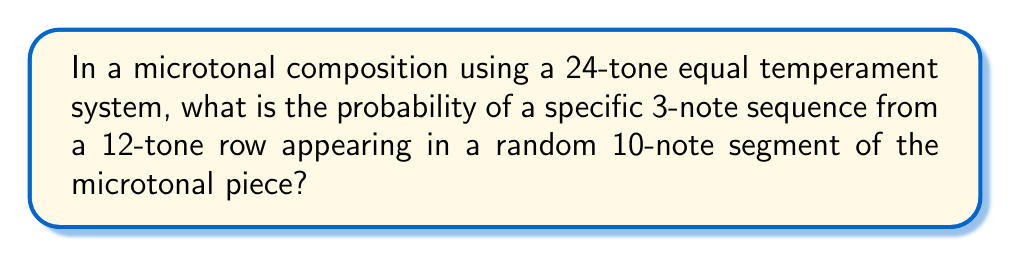Give your solution to this math problem. Let's approach this step-by-step:

1) First, we need to understand that in a 24-tone equal temperament system, there are 24 possible notes in each octave, compared to the 12 in standard tuning.

2) The 3-note sequence from the 12-tone row will map to specific notes in the 24-tone system. Each of these notes has a probability of $\frac{1}{24}$ of being chosen randomly.

3) For the 3-note sequence to appear, we need these specific 3 notes to appear in order within the 10-note segment. There are 8 possible starting positions for this 3-note sequence within a 10-note segment (positions 1-8).

4) The probability of the sequence starting at any given position is:

   $$P(\text{sequence at one position}) = (\frac{1}{24})^3 = \frac{1}{13824}$$

5) Since there are 8 possible starting positions, and these are mutually exclusive events (the sequence can't start at more than one position simultaneously), we can use the addition rule of probability:

   $$P(\text{sequence in 10-note segment}) = 8 \cdot \frac{1}{13824} = \frac{1}{1728}$$

6) This can be simplified to:

   $$P(\text{sequence in 10-note segment}) = \frac{5}{8640}$$
Answer: $\frac{5}{8640}$ 